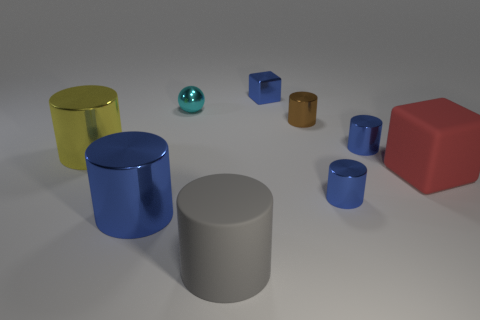Is there a gray matte cylinder on the right side of the block that is behind the small cyan sphere?
Keep it short and to the point. No. Are there any other things that have the same color as the big cube?
Your answer should be very brief. No. Is the blue cylinder that is left of the tiny metallic block made of the same material as the big red block?
Offer a very short reply. No. Is the number of tiny cylinders behind the brown object the same as the number of big objects to the right of the yellow thing?
Your response must be concise. No. How big is the blue metal thing that is to the left of the tiny blue object that is behind the metal sphere?
Keep it short and to the point. Large. What material is the blue thing that is to the left of the brown shiny cylinder and in front of the blue block?
Make the answer very short. Metal. How many other objects are there of the same size as the rubber block?
Give a very brief answer. 3. The small metal ball has what color?
Your answer should be compact. Cyan. There is a big matte object behind the matte cylinder; does it have the same color as the tiny object that is behind the cyan object?
Make the answer very short. No. The gray object is what size?
Make the answer very short. Large. 